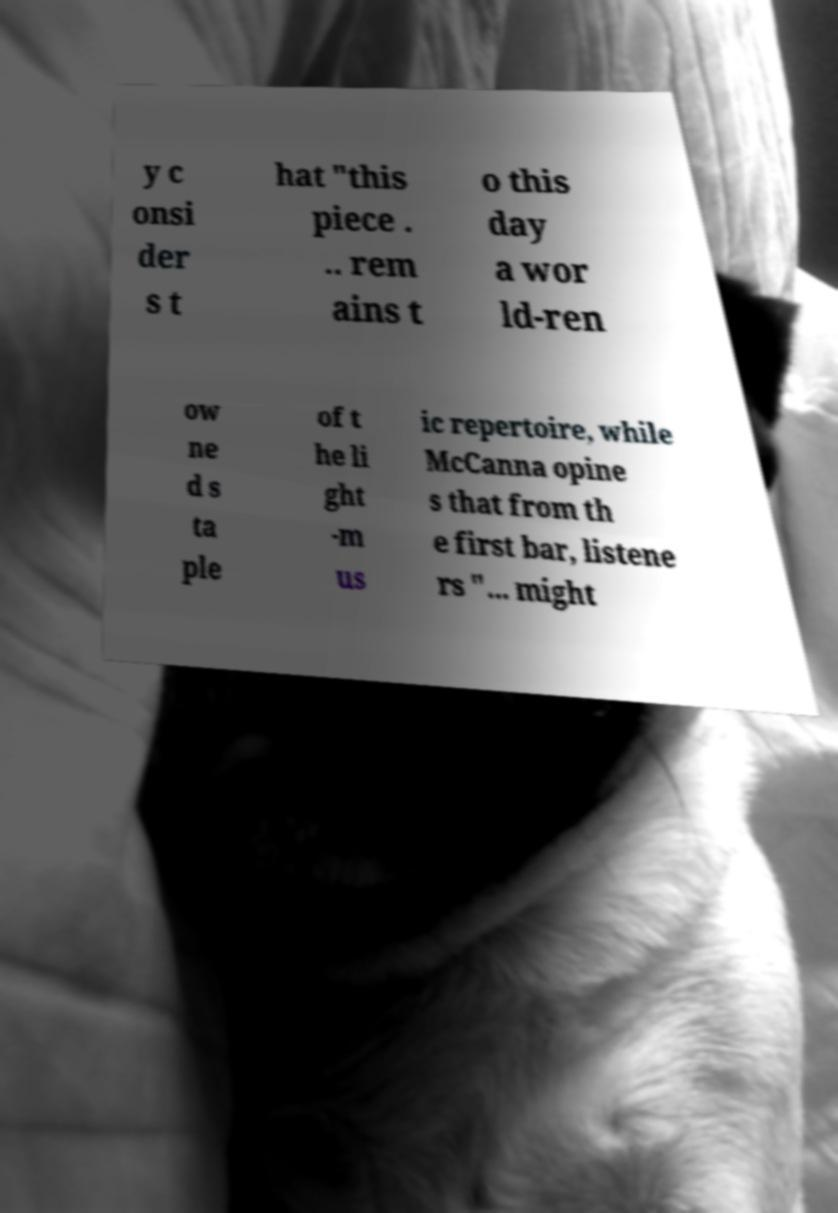What messages or text are displayed in this image? I need them in a readable, typed format. y c onsi der s t hat "this piece . .. rem ains t o this day a wor ld-ren ow ne d s ta ple of t he li ght -m us ic repertoire, while McCanna opine s that from th e first bar, listene rs "... might 